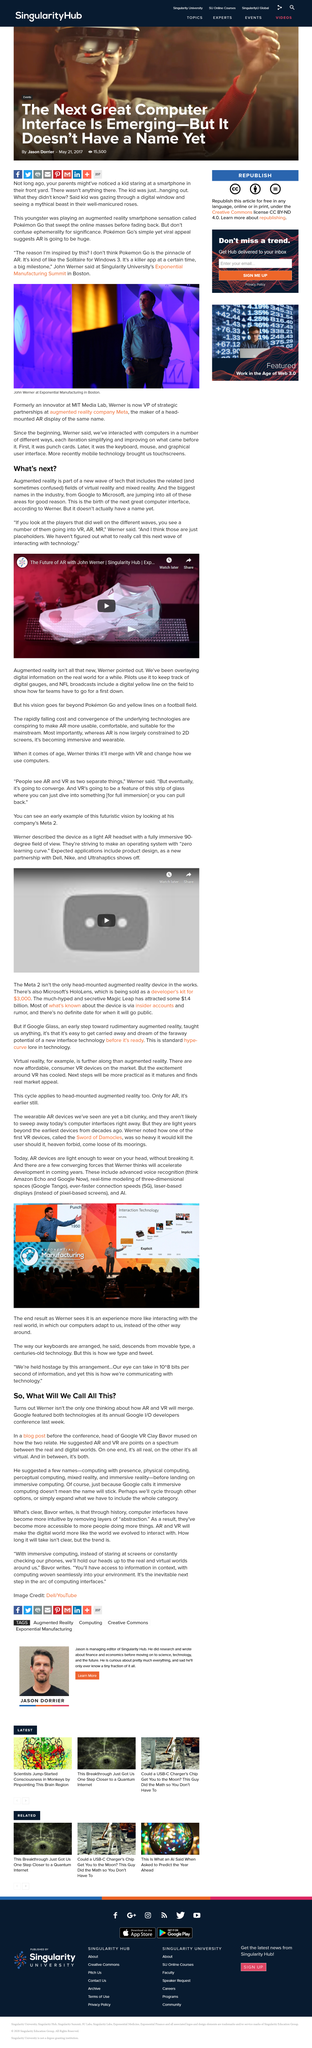Point out several critical features in this image. Werner thinks that VR and AR will merge. The abbreviations AR, VR, and MR refer to the concepts of Augmented Reality, Virtual Reality, and Mixed Reality, respectively. These terms describe technologies that enhance the real-world environment with digital information and immersive experiences. The two ends of the AR and VR spectrum are characterized by their predominant focus on either real or virtual experiences. At one end of the spectrum, the focus is on real experiences, while at the other end, the focus is on virtual experiences. John Werner does not believe that Pokemon Go is the pinnacle of AR. Instead, he considers it a killer app that achieved great success at a particular time and represented a significant milestone in the field of AR technology. The person in the photo is John Werner. 